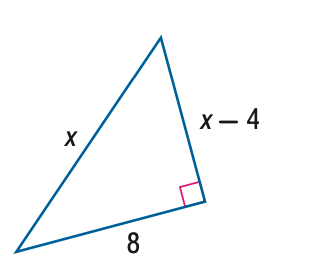Question: Find x.
Choices:
A. 8
B. 9
C. 10
D. 11
Answer with the letter. Answer: C 